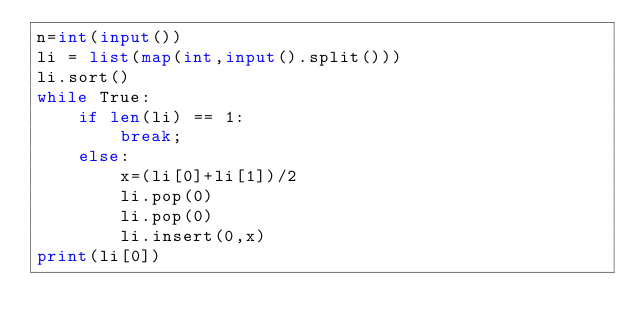<code> <loc_0><loc_0><loc_500><loc_500><_Python_>n=int(input())
li = list(map(int,input().split()))
li.sort()
while True:
    if len(li) == 1:
        break;
    else:
        x=(li[0]+li[1])/2
        li.pop(0)
        li.pop(0)
        li.insert(0,x)
print(li[0])</code> 